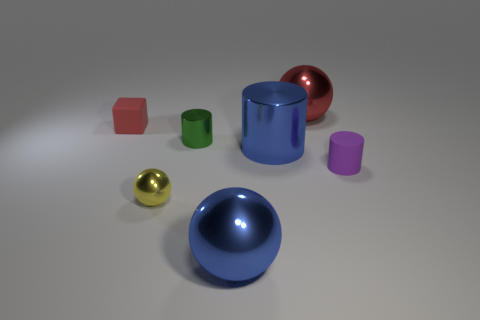Add 2 green cylinders. How many objects exist? 9 Subtract all blue spheres. How many spheres are left? 2 Subtract all cylinders. How many objects are left? 4 Subtract 1 spheres. How many spheres are left? 2 Subtract all purple cylinders. How many cylinders are left? 2 Add 1 tiny brown matte cylinders. How many tiny brown matte cylinders exist? 1 Subtract 0 brown blocks. How many objects are left? 7 Subtract all cyan blocks. Subtract all brown spheres. How many blocks are left? 1 Subtract all big blocks. Subtract all blue spheres. How many objects are left? 6 Add 7 big shiny cylinders. How many big shiny cylinders are left? 8 